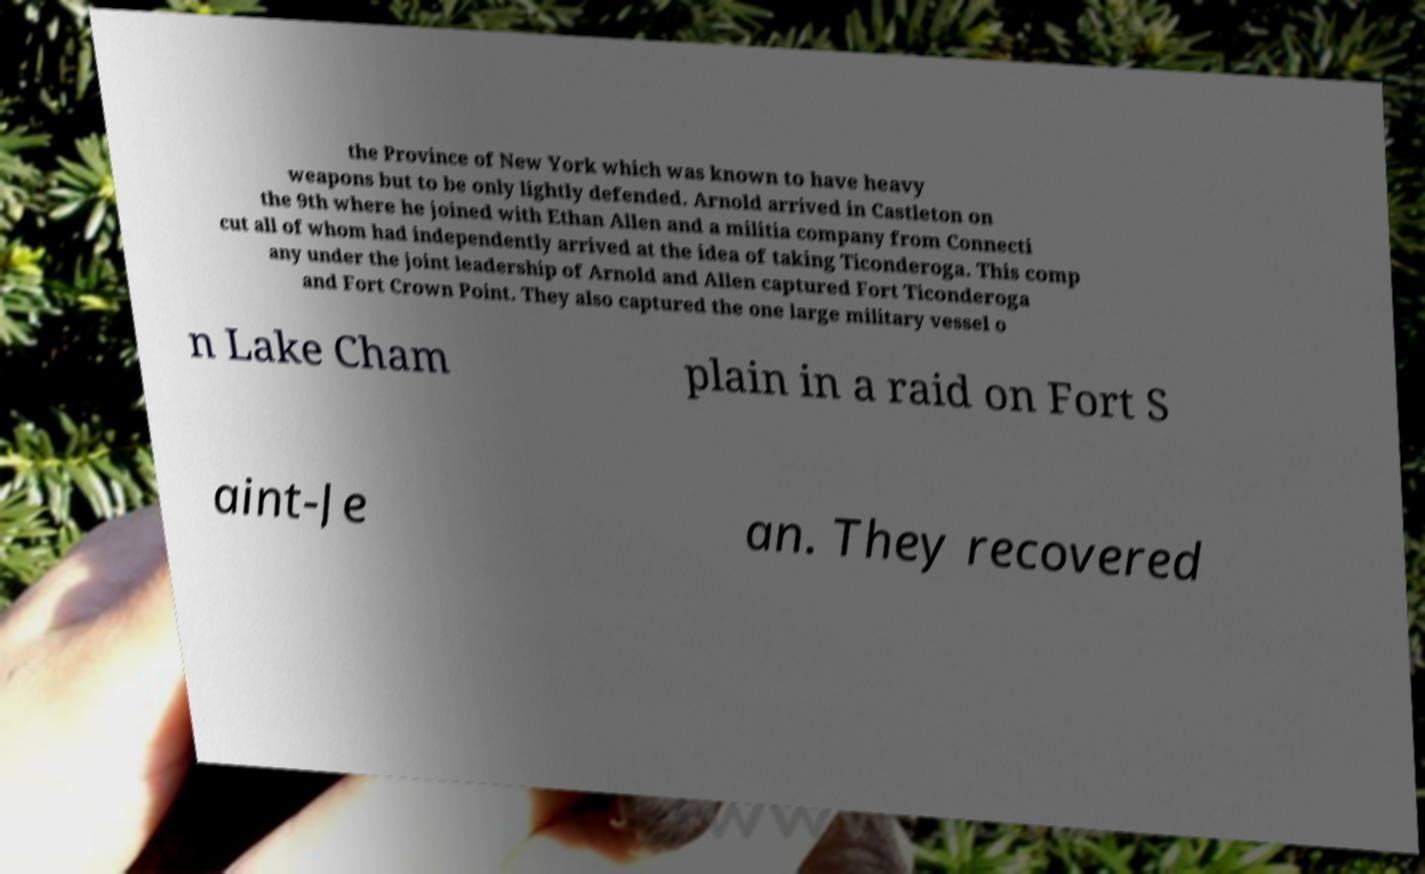Please identify and transcribe the text found in this image. the Province of New York which was known to have heavy weapons but to be only lightly defended. Arnold arrived in Castleton on the 9th where he joined with Ethan Allen and a militia company from Connecti cut all of whom had independently arrived at the idea of taking Ticonderoga. This comp any under the joint leadership of Arnold and Allen captured Fort Ticonderoga and Fort Crown Point. They also captured the one large military vessel o n Lake Cham plain in a raid on Fort S aint-Je an. They recovered 